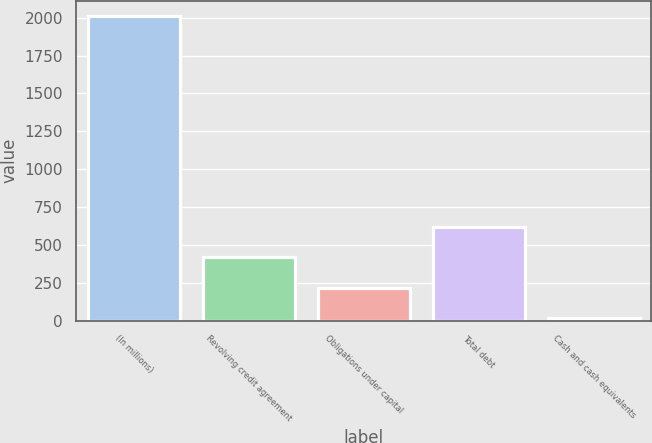Convert chart. <chart><loc_0><loc_0><loc_500><loc_500><bar_chart><fcel>(In millions)<fcel>Revolving credit agreement<fcel>Obligations under capital<fcel>Total debt<fcel>Cash and cash equivalents<nl><fcel>2010<fcel>416.64<fcel>217.47<fcel>615.81<fcel>18.3<nl></chart> 